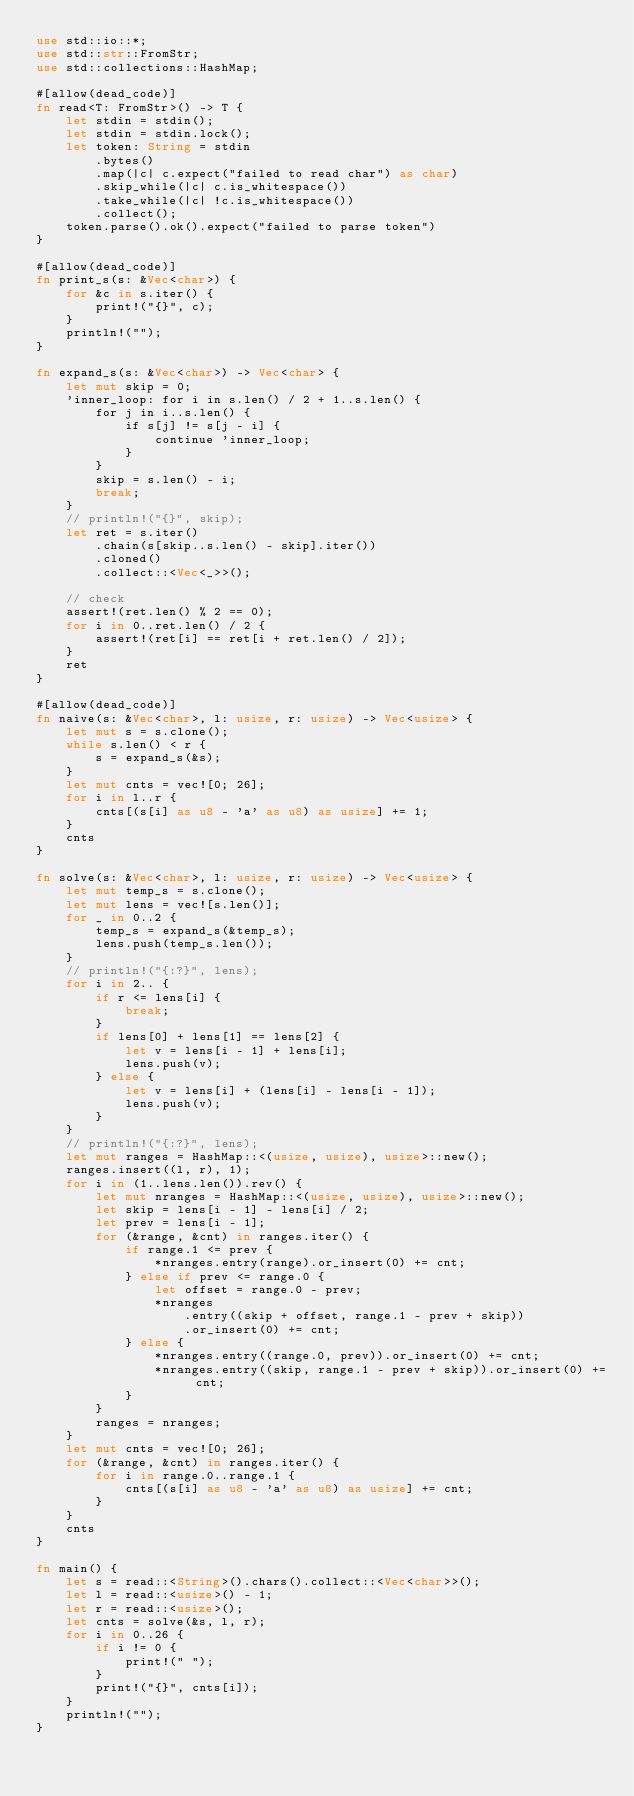<code> <loc_0><loc_0><loc_500><loc_500><_Rust_>use std::io::*;
use std::str::FromStr;
use std::collections::HashMap;

#[allow(dead_code)]
fn read<T: FromStr>() -> T {
    let stdin = stdin();
    let stdin = stdin.lock();
    let token: String = stdin
        .bytes()
        .map(|c| c.expect("failed to read char") as char)
        .skip_while(|c| c.is_whitespace())
        .take_while(|c| !c.is_whitespace())
        .collect();
    token.parse().ok().expect("failed to parse token")
}

#[allow(dead_code)]
fn print_s(s: &Vec<char>) {
    for &c in s.iter() {
        print!("{}", c);
    }
    println!("");
}

fn expand_s(s: &Vec<char>) -> Vec<char> {
    let mut skip = 0;
    'inner_loop: for i in s.len() / 2 + 1..s.len() {
        for j in i..s.len() {
            if s[j] != s[j - i] {
                continue 'inner_loop;
            }
        }
        skip = s.len() - i;
        break;
    }
    // println!("{}", skip);
    let ret = s.iter()
        .chain(s[skip..s.len() - skip].iter())
        .cloned()
        .collect::<Vec<_>>();

    // check
    assert!(ret.len() % 2 == 0);
    for i in 0..ret.len() / 2 {
        assert!(ret[i] == ret[i + ret.len() / 2]);
    }
    ret
}

#[allow(dead_code)]
fn naive(s: &Vec<char>, l: usize, r: usize) -> Vec<usize> {
    let mut s = s.clone();
    while s.len() < r {
        s = expand_s(&s);
    }
    let mut cnts = vec![0; 26];
    for i in l..r {
        cnts[(s[i] as u8 - 'a' as u8) as usize] += 1;
    }
    cnts
}

fn solve(s: &Vec<char>, l: usize, r: usize) -> Vec<usize> {
    let mut temp_s = s.clone();
    let mut lens = vec![s.len()];
    for _ in 0..2 {
        temp_s = expand_s(&temp_s);
        lens.push(temp_s.len());
    }
    // println!("{:?}", lens);
    for i in 2.. {
        if r <= lens[i] {
            break;
        }
        if lens[0] + lens[1] == lens[2] {
            let v = lens[i - 1] + lens[i];
            lens.push(v);
        } else {
            let v = lens[i] + (lens[i] - lens[i - 1]);
            lens.push(v);
        }
    }
    // println!("{:?}", lens);
    let mut ranges = HashMap::<(usize, usize), usize>::new();
    ranges.insert((l, r), 1);
    for i in (1..lens.len()).rev() {
        let mut nranges = HashMap::<(usize, usize), usize>::new();
        let skip = lens[i - 1] - lens[i] / 2;
        let prev = lens[i - 1];
        for (&range, &cnt) in ranges.iter() {
            if range.1 <= prev {
                *nranges.entry(range).or_insert(0) += cnt;
            } else if prev <= range.0 {
                let offset = range.0 - prev;
                *nranges
                    .entry((skip + offset, range.1 - prev + skip))
                    .or_insert(0) += cnt;
            } else {
                *nranges.entry((range.0, prev)).or_insert(0) += cnt;
                *nranges.entry((skip, range.1 - prev + skip)).or_insert(0) += cnt;
            }
        }
        ranges = nranges;
    }
    let mut cnts = vec![0; 26];
    for (&range, &cnt) in ranges.iter() {
        for i in range.0..range.1 {
            cnts[(s[i] as u8 - 'a' as u8) as usize] += cnt;
        }
    }
    cnts
}

fn main() {
    let s = read::<String>().chars().collect::<Vec<char>>();
    let l = read::<usize>() - 1;
    let r = read::<usize>();
    let cnts = solve(&s, l, r);
    for i in 0..26 {
        if i != 0 {
            print!(" ");
        }
        print!("{}", cnts[i]);
    }
    println!("");
}
</code> 